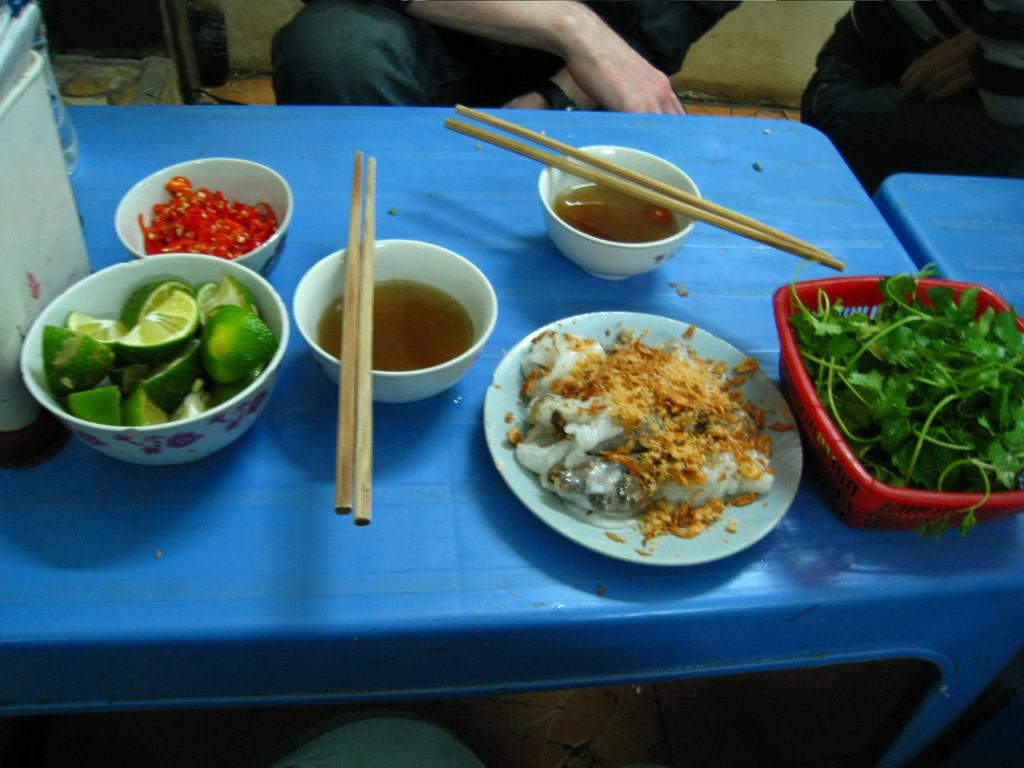What type of furniture is visible in the image? There are tables in the image. What is on top of the table? There are food items in a bowl on top of the table. What utensils are present in the image? Chopsticks are present in the image. Are there any people in the image? Yes, there are people near the table. What type of stitch is being used to hold the band together in the image? There is no band or stitch present in the image. What type of zephyr can be seen blowing through the scene in the image? There is no zephyr present in the image. 